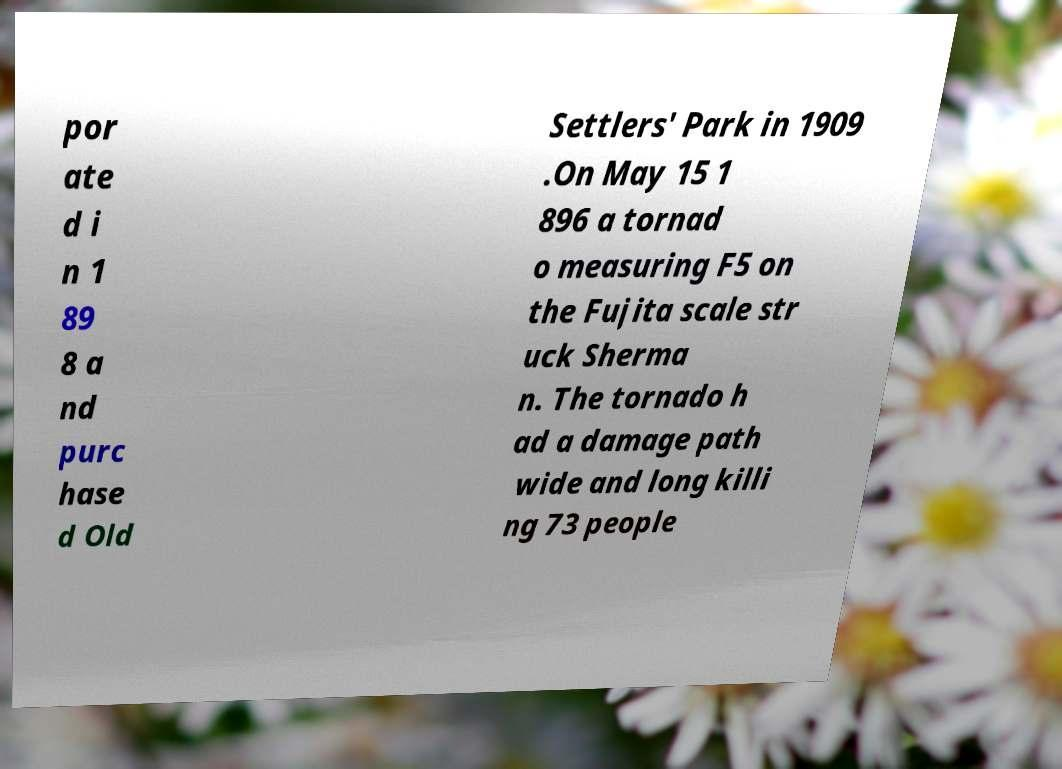I need the written content from this picture converted into text. Can you do that? por ate d i n 1 89 8 a nd purc hase d Old Settlers' Park in 1909 .On May 15 1 896 a tornad o measuring F5 on the Fujita scale str uck Sherma n. The tornado h ad a damage path wide and long killi ng 73 people 